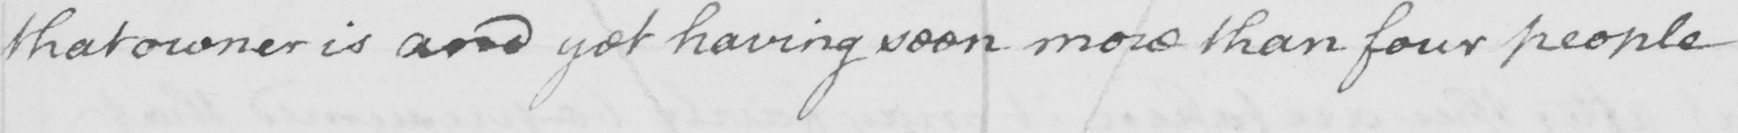Transcribe the text shown in this historical manuscript line. that owner is and yet not having seen more than four people 